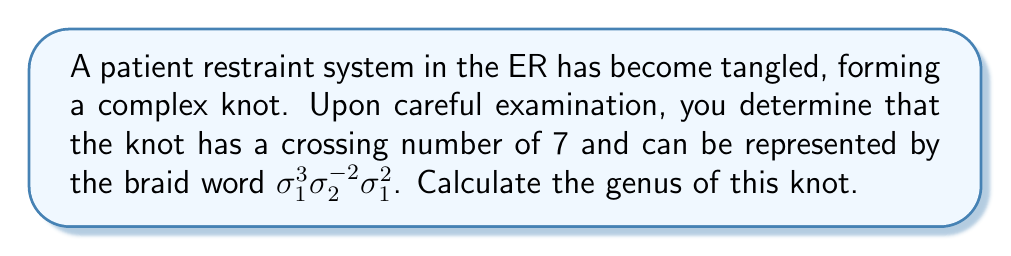Help me with this question. To evaluate the genus of the knot, we'll follow these steps:

1. Determine the number of strands in the braid:
   The braid word uses $\sigma_1$ and $\sigma_2$, indicating a 3-strand braid.

2. Calculate the writhe of the braid:
   Writhe = (number of positive crossings) - (number of negative crossings)
   $w = (3 + 2) - 2 = 3$

3. Find the number of components in the link:
   This is a knot, so it has only one component.

4. Use the formula for the genus of a knot:
   $$g = \frac{1}{2}(c - s - w + 2)$$
   Where:
   $g$ = genus
   $c$ = crossing number (given as 7)
   $s$ = number of components (1 for a knot)
   $w$ = writhe (calculated as 3)

5. Substitute the values into the formula:
   $$g = \frac{1}{2}(7 - 1 - 3 + 2)$$
   $$g = \frac{1}{2}(5)$$
   $$g = \frac{5}{2}$$

6. Since the genus must be an integer, we round up to the nearest whole number:
   $$g = 3$$
Answer: 3 